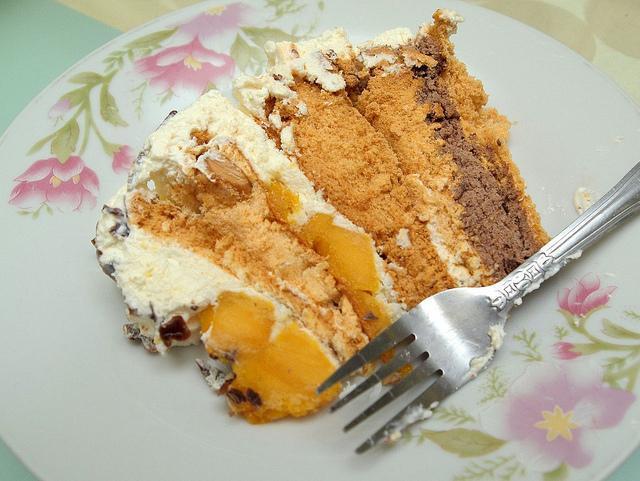How many other animals besides the giraffe are in the picture?
Give a very brief answer. 0. 